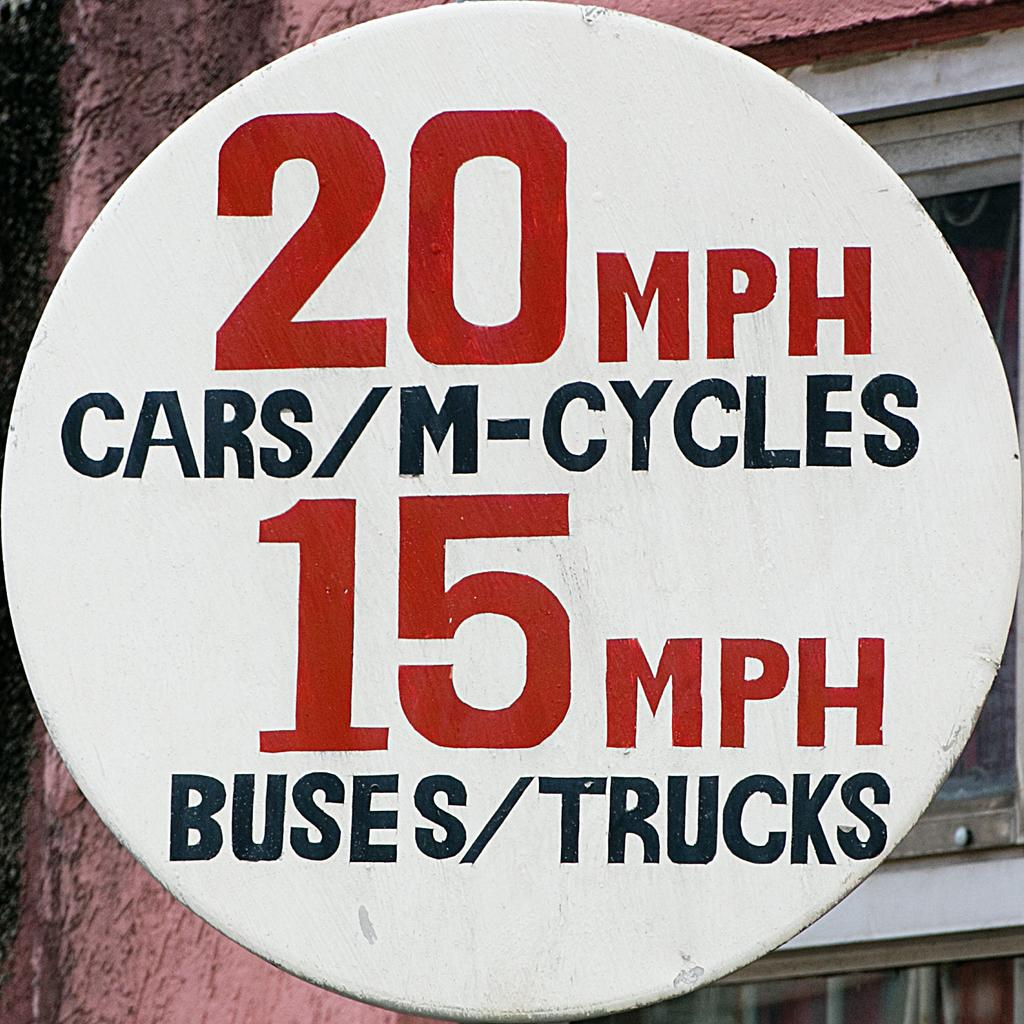Provide a one-sentence caption for the provided image. 20 mph is the speed limit for cars and bicycles according to the sign. 